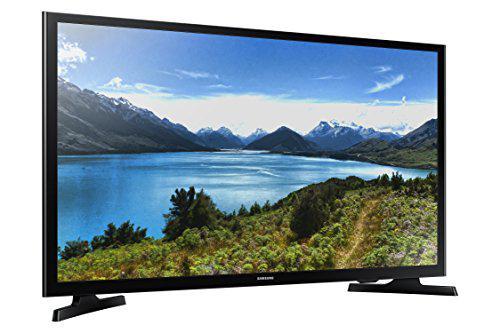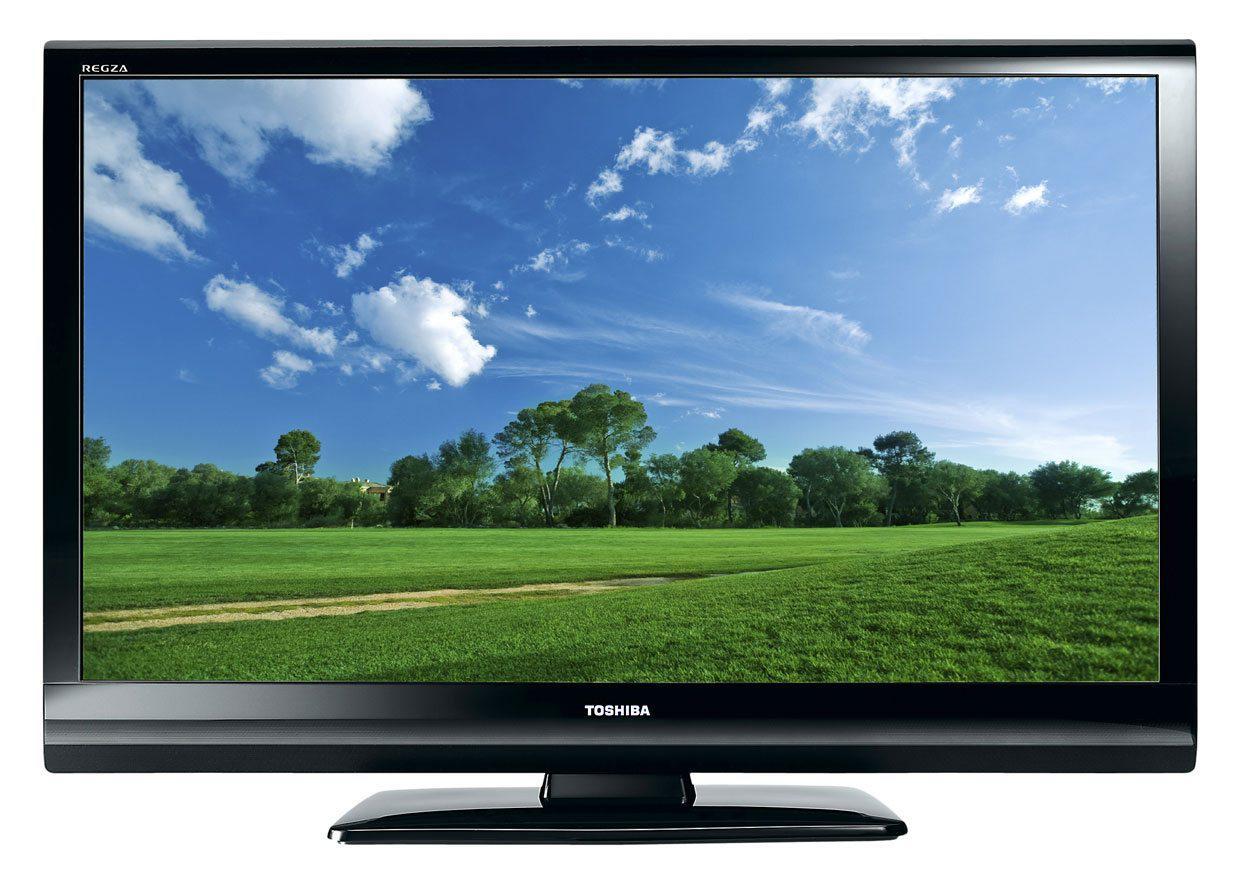The first image is the image on the left, the second image is the image on the right. Examine the images to the left and right. Is the description "One screen is tilted to the right and shows mountains in front of a lake, and the other screen is viewed head-on and shows a different landscape scene." accurate? Answer yes or no. Yes. The first image is the image on the left, the second image is the image on the right. Evaluate the accuracy of this statement regarding the images: "One of the screens is showing a tropical scene.". Is it true? Answer yes or no. No. 